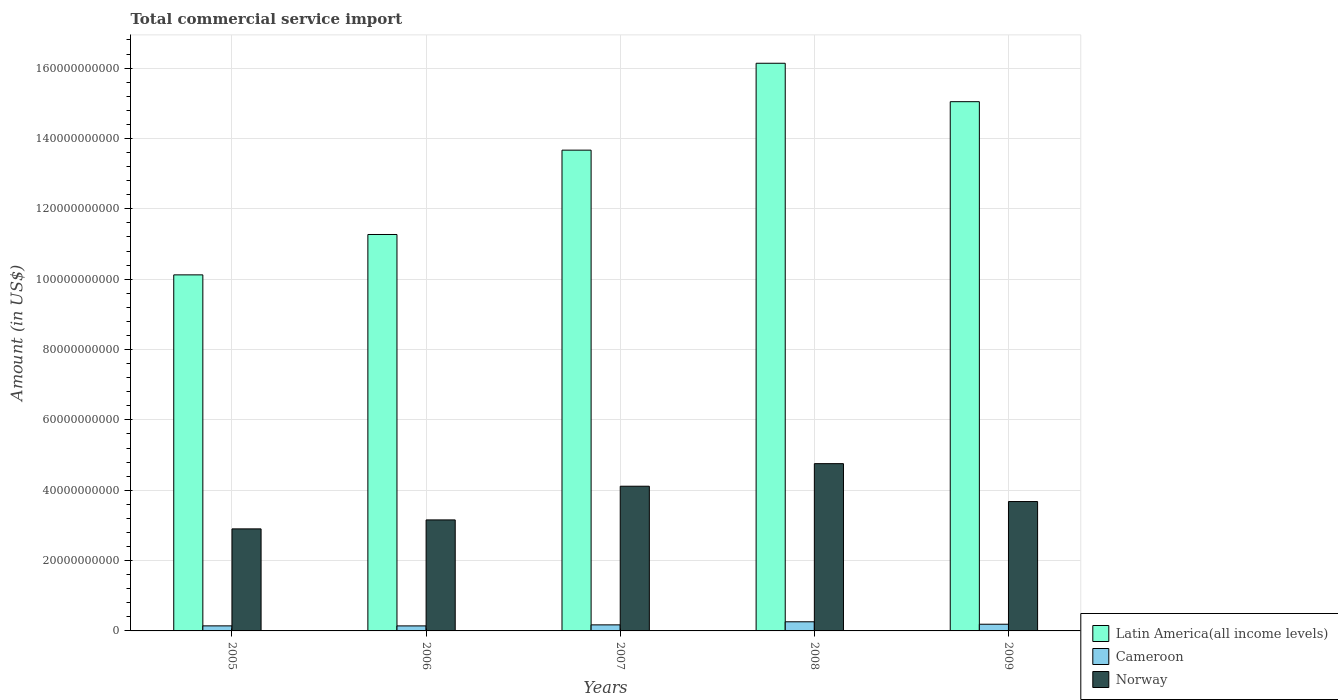How many groups of bars are there?
Your answer should be very brief. 5. Are the number of bars per tick equal to the number of legend labels?
Your answer should be compact. Yes. How many bars are there on the 5th tick from the left?
Make the answer very short. 3. What is the label of the 4th group of bars from the left?
Your answer should be compact. 2008. In how many cases, is the number of bars for a given year not equal to the number of legend labels?
Provide a short and direct response. 0. What is the total commercial service import in Norway in 2008?
Your answer should be very brief. 4.76e+1. Across all years, what is the maximum total commercial service import in Norway?
Provide a short and direct response. 4.76e+1. Across all years, what is the minimum total commercial service import in Cameroon?
Provide a succinct answer. 1.43e+09. In which year was the total commercial service import in Cameroon maximum?
Offer a very short reply. 2008. In which year was the total commercial service import in Norway minimum?
Your response must be concise. 2005. What is the total total commercial service import in Cameroon in the graph?
Your answer should be compact. 9.08e+09. What is the difference between the total commercial service import in Latin America(all income levels) in 2006 and that in 2009?
Your response must be concise. -3.78e+1. What is the difference between the total commercial service import in Latin America(all income levels) in 2007 and the total commercial service import in Norway in 2005?
Give a very brief answer. 1.08e+11. What is the average total commercial service import in Cameroon per year?
Offer a very short reply. 1.82e+09. In the year 2008, what is the difference between the total commercial service import in Norway and total commercial service import in Cameroon?
Give a very brief answer. 4.50e+1. In how many years, is the total commercial service import in Latin America(all income levels) greater than 128000000000 US$?
Keep it short and to the point. 3. What is the ratio of the total commercial service import in Cameroon in 2006 to that in 2007?
Offer a terse response. 0.83. Is the total commercial service import in Cameroon in 2008 less than that in 2009?
Offer a very short reply. No. Is the difference between the total commercial service import in Norway in 2006 and 2008 greater than the difference between the total commercial service import in Cameroon in 2006 and 2008?
Provide a short and direct response. No. What is the difference between the highest and the second highest total commercial service import in Norway?
Your answer should be compact. 6.42e+09. What is the difference between the highest and the lowest total commercial service import in Cameroon?
Your response must be concise. 1.17e+09. Is the sum of the total commercial service import in Norway in 2005 and 2007 greater than the maximum total commercial service import in Latin America(all income levels) across all years?
Give a very brief answer. No. What does the 3rd bar from the left in 2006 represents?
Offer a very short reply. Norway. How many bars are there?
Provide a succinct answer. 15. How many years are there in the graph?
Ensure brevity in your answer.  5. What is the difference between two consecutive major ticks on the Y-axis?
Make the answer very short. 2.00e+1. Does the graph contain grids?
Your response must be concise. Yes. How are the legend labels stacked?
Your answer should be compact. Vertical. What is the title of the graph?
Your answer should be compact. Total commercial service import. What is the label or title of the X-axis?
Offer a very short reply. Years. What is the label or title of the Y-axis?
Offer a terse response. Amount (in US$). What is the Amount (in US$) in Latin America(all income levels) in 2005?
Your answer should be compact. 1.01e+11. What is the Amount (in US$) of Cameroon in 2005?
Ensure brevity in your answer.  1.44e+09. What is the Amount (in US$) of Norway in 2005?
Your answer should be very brief. 2.90e+1. What is the Amount (in US$) of Latin America(all income levels) in 2006?
Ensure brevity in your answer.  1.13e+11. What is the Amount (in US$) in Cameroon in 2006?
Make the answer very short. 1.43e+09. What is the Amount (in US$) of Norway in 2006?
Your answer should be compact. 3.16e+1. What is the Amount (in US$) in Latin America(all income levels) in 2007?
Provide a succinct answer. 1.37e+11. What is the Amount (in US$) in Cameroon in 2007?
Give a very brief answer. 1.72e+09. What is the Amount (in US$) of Norway in 2007?
Ensure brevity in your answer.  4.11e+1. What is the Amount (in US$) in Latin America(all income levels) in 2008?
Offer a terse response. 1.61e+11. What is the Amount (in US$) in Cameroon in 2008?
Your answer should be very brief. 2.60e+09. What is the Amount (in US$) of Norway in 2008?
Offer a very short reply. 4.76e+1. What is the Amount (in US$) of Latin America(all income levels) in 2009?
Give a very brief answer. 1.50e+11. What is the Amount (in US$) in Cameroon in 2009?
Keep it short and to the point. 1.90e+09. What is the Amount (in US$) of Norway in 2009?
Offer a terse response. 3.68e+1. Across all years, what is the maximum Amount (in US$) of Latin America(all income levels)?
Give a very brief answer. 1.61e+11. Across all years, what is the maximum Amount (in US$) in Cameroon?
Give a very brief answer. 2.60e+09. Across all years, what is the maximum Amount (in US$) in Norway?
Your answer should be compact. 4.76e+1. Across all years, what is the minimum Amount (in US$) of Latin America(all income levels)?
Your answer should be compact. 1.01e+11. Across all years, what is the minimum Amount (in US$) in Cameroon?
Keep it short and to the point. 1.43e+09. Across all years, what is the minimum Amount (in US$) of Norway?
Make the answer very short. 2.90e+1. What is the total Amount (in US$) in Latin America(all income levels) in the graph?
Make the answer very short. 6.62e+11. What is the total Amount (in US$) in Cameroon in the graph?
Your answer should be compact. 9.08e+09. What is the total Amount (in US$) in Norway in the graph?
Provide a succinct answer. 1.86e+11. What is the difference between the Amount (in US$) in Latin America(all income levels) in 2005 and that in 2006?
Provide a short and direct response. -1.15e+1. What is the difference between the Amount (in US$) of Cameroon in 2005 and that in 2006?
Offer a terse response. 9.96e+06. What is the difference between the Amount (in US$) of Norway in 2005 and that in 2006?
Offer a terse response. -2.55e+09. What is the difference between the Amount (in US$) of Latin America(all income levels) in 2005 and that in 2007?
Ensure brevity in your answer.  -3.55e+1. What is the difference between the Amount (in US$) in Cameroon in 2005 and that in 2007?
Ensure brevity in your answer.  -2.83e+08. What is the difference between the Amount (in US$) in Norway in 2005 and that in 2007?
Make the answer very short. -1.21e+1. What is the difference between the Amount (in US$) of Latin America(all income levels) in 2005 and that in 2008?
Provide a succinct answer. -6.02e+1. What is the difference between the Amount (in US$) of Cameroon in 2005 and that in 2008?
Keep it short and to the point. -1.16e+09. What is the difference between the Amount (in US$) in Norway in 2005 and that in 2008?
Keep it short and to the point. -1.85e+1. What is the difference between the Amount (in US$) in Latin America(all income levels) in 2005 and that in 2009?
Give a very brief answer. -4.92e+1. What is the difference between the Amount (in US$) of Cameroon in 2005 and that in 2009?
Offer a terse response. -4.66e+08. What is the difference between the Amount (in US$) of Norway in 2005 and that in 2009?
Make the answer very short. -7.77e+09. What is the difference between the Amount (in US$) in Latin America(all income levels) in 2006 and that in 2007?
Provide a short and direct response. -2.40e+1. What is the difference between the Amount (in US$) in Cameroon in 2006 and that in 2007?
Offer a very short reply. -2.93e+08. What is the difference between the Amount (in US$) in Norway in 2006 and that in 2007?
Keep it short and to the point. -9.58e+09. What is the difference between the Amount (in US$) of Latin America(all income levels) in 2006 and that in 2008?
Your response must be concise. -4.87e+1. What is the difference between the Amount (in US$) of Cameroon in 2006 and that in 2008?
Keep it short and to the point. -1.17e+09. What is the difference between the Amount (in US$) of Norway in 2006 and that in 2008?
Make the answer very short. -1.60e+1. What is the difference between the Amount (in US$) in Latin America(all income levels) in 2006 and that in 2009?
Offer a very short reply. -3.78e+1. What is the difference between the Amount (in US$) of Cameroon in 2006 and that in 2009?
Keep it short and to the point. -4.75e+08. What is the difference between the Amount (in US$) in Norway in 2006 and that in 2009?
Give a very brief answer. -5.22e+09. What is the difference between the Amount (in US$) of Latin America(all income levels) in 2007 and that in 2008?
Give a very brief answer. -2.47e+1. What is the difference between the Amount (in US$) of Cameroon in 2007 and that in 2008?
Offer a very short reply. -8.77e+08. What is the difference between the Amount (in US$) in Norway in 2007 and that in 2008?
Provide a short and direct response. -6.42e+09. What is the difference between the Amount (in US$) in Latin America(all income levels) in 2007 and that in 2009?
Your answer should be compact. -1.38e+1. What is the difference between the Amount (in US$) of Cameroon in 2007 and that in 2009?
Your answer should be very brief. -1.83e+08. What is the difference between the Amount (in US$) of Norway in 2007 and that in 2009?
Offer a very short reply. 4.35e+09. What is the difference between the Amount (in US$) in Latin America(all income levels) in 2008 and that in 2009?
Offer a very short reply. 1.09e+1. What is the difference between the Amount (in US$) of Cameroon in 2008 and that in 2009?
Ensure brevity in your answer.  6.94e+08. What is the difference between the Amount (in US$) in Norway in 2008 and that in 2009?
Provide a short and direct response. 1.08e+1. What is the difference between the Amount (in US$) in Latin America(all income levels) in 2005 and the Amount (in US$) in Cameroon in 2006?
Your answer should be very brief. 9.98e+1. What is the difference between the Amount (in US$) of Latin America(all income levels) in 2005 and the Amount (in US$) of Norway in 2006?
Keep it short and to the point. 6.97e+1. What is the difference between the Amount (in US$) in Cameroon in 2005 and the Amount (in US$) in Norway in 2006?
Provide a succinct answer. -3.01e+1. What is the difference between the Amount (in US$) of Latin America(all income levels) in 2005 and the Amount (in US$) of Cameroon in 2007?
Keep it short and to the point. 9.95e+1. What is the difference between the Amount (in US$) of Latin America(all income levels) in 2005 and the Amount (in US$) of Norway in 2007?
Provide a succinct answer. 6.01e+1. What is the difference between the Amount (in US$) in Cameroon in 2005 and the Amount (in US$) in Norway in 2007?
Give a very brief answer. -3.97e+1. What is the difference between the Amount (in US$) of Latin America(all income levels) in 2005 and the Amount (in US$) of Cameroon in 2008?
Ensure brevity in your answer.  9.86e+1. What is the difference between the Amount (in US$) in Latin America(all income levels) in 2005 and the Amount (in US$) in Norway in 2008?
Offer a terse response. 5.37e+1. What is the difference between the Amount (in US$) in Cameroon in 2005 and the Amount (in US$) in Norway in 2008?
Your answer should be compact. -4.61e+1. What is the difference between the Amount (in US$) of Latin America(all income levels) in 2005 and the Amount (in US$) of Cameroon in 2009?
Offer a very short reply. 9.93e+1. What is the difference between the Amount (in US$) in Latin America(all income levels) in 2005 and the Amount (in US$) in Norway in 2009?
Offer a terse response. 6.44e+1. What is the difference between the Amount (in US$) of Cameroon in 2005 and the Amount (in US$) of Norway in 2009?
Ensure brevity in your answer.  -3.53e+1. What is the difference between the Amount (in US$) in Latin America(all income levels) in 2006 and the Amount (in US$) in Cameroon in 2007?
Make the answer very short. 1.11e+11. What is the difference between the Amount (in US$) of Latin America(all income levels) in 2006 and the Amount (in US$) of Norway in 2007?
Ensure brevity in your answer.  7.16e+1. What is the difference between the Amount (in US$) of Cameroon in 2006 and the Amount (in US$) of Norway in 2007?
Provide a succinct answer. -3.97e+1. What is the difference between the Amount (in US$) of Latin America(all income levels) in 2006 and the Amount (in US$) of Cameroon in 2008?
Provide a short and direct response. 1.10e+11. What is the difference between the Amount (in US$) in Latin America(all income levels) in 2006 and the Amount (in US$) in Norway in 2008?
Offer a terse response. 6.51e+1. What is the difference between the Amount (in US$) of Cameroon in 2006 and the Amount (in US$) of Norway in 2008?
Offer a very short reply. -4.61e+1. What is the difference between the Amount (in US$) in Latin America(all income levels) in 2006 and the Amount (in US$) in Cameroon in 2009?
Your response must be concise. 1.11e+11. What is the difference between the Amount (in US$) in Latin America(all income levels) in 2006 and the Amount (in US$) in Norway in 2009?
Your answer should be very brief. 7.59e+1. What is the difference between the Amount (in US$) in Cameroon in 2006 and the Amount (in US$) in Norway in 2009?
Provide a short and direct response. -3.54e+1. What is the difference between the Amount (in US$) in Latin America(all income levels) in 2007 and the Amount (in US$) in Cameroon in 2008?
Provide a succinct answer. 1.34e+11. What is the difference between the Amount (in US$) in Latin America(all income levels) in 2007 and the Amount (in US$) in Norway in 2008?
Your answer should be very brief. 8.91e+1. What is the difference between the Amount (in US$) in Cameroon in 2007 and the Amount (in US$) in Norway in 2008?
Your answer should be compact. -4.58e+1. What is the difference between the Amount (in US$) of Latin America(all income levels) in 2007 and the Amount (in US$) of Cameroon in 2009?
Give a very brief answer. 1.35e+11. What is the difference between the Amount (in US$) in Latin America(all income levels) in 2007 and the Amount (in US$) in Norway in 2009?
Give a very brief answer. 9.99e+1. What is the difference between the Amount (in US$) in Cameroon in 2007 and the Amount (in US$) in Norway in 2009?
Offer a very short reply. -3.51e+1. What is the difference between the Amount (in US$) in Latin America(all income levels) in 2008 and the Amount (in US$) in Cameroon in 2009?
Make the answer very short. 1.59e+11. What is the difference between the Amount (in US$) of Latin America(all income levels) in 2008 and the Amount (in US$) of Norway in 2009?
Your answer should be very brief. 1.25e+11. What is the difference between the Amount (in US$) in Cameroon in 2008 and the Amount (in US$) in Norway in 2009?
Your response must be concise. -3.42e+1. What is the average Amount (in US$) in Latin America(all income levels) per year?
Provide a succinct answer. 1.32e+11. What is the average Amount (in US$) of Cameroon per year?
Provide a short and direct response. 1.82e+09. What is the average Amount (in US$) of Norway per year?
Make the answer very short. 3.72e+1. In the year 2005, what is the difference between the Amount (in US$) in Latin America(all income levels) and Amount (in US$) in Cameroon?
Your answer should be compact. 9.98e+1. In the year 2005, what is the difference between the Amount (in US$) of Latin America(all income levels) and Amount (in US$) of Norway?
Your response must be concise. 7.22e+1. In the year 2005, what is the difference between the Amount (in US$) of Cameroon and Amount (in US$) of Norway?
Give a very brief answer. -2.76e+1. In the year 2006, what is the difference between the Amount (in US$) in Latin America(all income levels) and Amount (in US$) in Cameroon?
Keep it short and to the point. 1.11e+11. In the year 2006, what is the difference between the Amount (in US$) in Latin America(all income levels) and Amount (in US$) in Norway?
Provide a succinct answer. 8.11e+1. In the year 2006, what is the difference between the Amount (in US$) of Cameroon and Amount (in US$) of Norway?
Make the answer very short. -3.01e+1. In the year 2007, what is the difference between the Amount (in US$) in Latin America(all income levels) and Amount (in US$) in Cameroon?
Provide a succinct answer. 1.35e+11. In the year 2007, what is the difference between the Amount (in US$) in Latin America(all income levels) and Amount (in US$) in Norway?
Provide a short and direct response. 9.55e+1. In the year 2007, what is the difference between the Amount (in US$) of Cameroon and Amount (in US$) of Norway?
Ensure brevity in your answer.  -3.94e+1. In the year 2008, what is the difference between the Amount (in US$) in Latin America(all income levels) and Amount (in US$) in Cameroon?
Provide a short and direct response. 1.59e+11. In the year 2008, what is the difference between the Amount (in US$) of Latin America(all income levels) and Amount (in US$) of Norway?
Provide a short and direct response. 1.14e+11. In the year 2008, what is the difference between the Amount (in US$) in Cameroon and Amount (in US$) in Norway?
Your answer should be compact. -4.50e+1. In the year 2009, what is the difference between the Amount (in US$) of Latin America(all income levels) and Amount (in US$) of Cameroon?
Make the answer very short. 1.49e+11. In the year 2009, what is the difference between the Amount (in US$) of Latin America(all income levels) and Amount (in US$) of Norway?
Your response must be concise. 1.14e+11. In the year 2009, what is the difference between the Amount (in US$) in Cameroon and Amount (in US$) in Norway?
Keep it short and to the point. -3.49e+1. What is the ratio of the Amount (in US$) of Latin America(all income levels) in 2005 to that in 2006?
Make the answer very short. 0.9. What is the ratio of the Amount (in US$) of Norway in 2005 to that in 2006?
Ensure brevity in your answer.  0.92. What is the ratio of the Amount (in US$) in Latin America(all income levels) in 2005 to that in 2007?
Ensure brevity in your answer.  0.74. What is the ratio of the Amount (in US$) in Cameroon in 2005 to that in 2007?
Give a very brief answer. 0.84. What is the ratio of the Amount (in US$) of Norway in 2005 to that in 2007?
Make the answer very short. 0.71. What is the ratio of the Amount (in US$) of Latin America(all income levels) in 2005 to that in 2008?
Offer a terse response. 0.63. What is the ratio of the Amount (in US$) of Cameroon in 2005 to that in 2008?
Make the answer very short. 0.55. What is the ratio of the Amount (in US$) in Norway in 2005 to that in 2008?
Give a very brief answer. 0.61. What is the ratio of the Amount (in US$) of Latin America(all income levels) in 2005 to that in 2009?
Your response must be concise. 0.67. What is the ratio of the Amount (in US$) in Cameroon in 2005 to that in 2009?
Ensure brevity in your answer.  0.76. What is the ratio of the Amount (in US$) in Norway in 2005 to that in 2009?
Make the answer very short. 0.79. What is the ratio of the Amount (in US$) in Latin America(all income levels) in 2006 to that in 2007?
Keep it short and to the point. 0.82. What is the ratio of the Amount (in US$) of Cameroon in 2006 to that in 2007?
Provide a short and direct response. 0.83. What is the ratio of the Amount (in US$) of Norway in 2006 to that in 2007?
Give a very brief answer. 0.77. What is the ratio of the Amount (in US$) in Latin America(all income levels) in 2006 to that in 2008?
Keep it short and to the point. 0.7. What is the ratio of the Amount (in US$) of Cameroon in 2006 to that in 2008?
Provide a succinct answer. 0.55. What is the ratio of the Amount (in US$) in Norway in 2006 to that in 2008?
Keep it short and to the point. 0.66. What is the ratio of the Amount (in US$) in Latin America(all income levels) in 2006 to that in 2009?
Provide a succinct answer. 0.75. What is the ratio of the Amount (in US$) of Cameroon in 2006 to that in 2009?
Ensure brevity in your answer.  0.75. What is the ratio of the Amount (in US$) in Norway in 2006 to that in 2009?
Your answer should be very brief. 0.86. What is the ratio of the Amount (in US$) in Latin America(all income levels) in 2007 to that in 2008?
Offer a terse response. 0.85. What is the ratio of the Amount (in US$) in Cameroon in 2007 to that in 2008?
Make the answer very short. 0.66. What is the ratio of the Amount (in US$) of Norway in 2007 to that in 2008?
Make the answer very short. 0.86. What is the ratio of the Amount (in US$) in Latin America(all income levels) in 2007 to that in 2009?
Offer a terse response. 0.91. What is the ratio of the Amount (in US$) of Cameroon in 2007 to that in 2009?
Offer a terse response. 0.9. What is the ratio of the Amount (in US$) of Norway in 2007 to that in 2009?
Give a very brief answer. 1.12. What is the ratio of the Amount (in US$) of Latin America(all income levels) in 2008 to that in 2009?
Offer a very short reply. 1.07. What is the ratio of the Amount (in US$) in Cameroon in 2008 to that in 2009?
Your answer should be compact. 1.36. What is the ratio of the Amount (in US$) of Norway in 2008 to that in 2009?
Offer a terse response. 1.29. What is the difference between the highest and the second highest Amount (in US$) in Latin America(all income levels)?
Your answer should be very brief. 1.09e+1. What is the difference between the highest and the second highest Amount (in US$) of Cameroon?
Give a very brief answer. 6.94e+08. What is the difference between the highest and the second highest Amount (in US$) of Norway?
Offer a terse response. 6.42e+09. What is the difference between the highest and the lowest Amount (in US$) of Latin America(all income levels)?
Keep it short and to the point. 6.02e+1. What is the difference between the highest and the lowest Amount (in US$) in Cameroon?
Offer a terse response. 1.17e+09. What is the difference between the highest and the lowest Amount (in US$) of Norway?
Provide a short and direct response. 1.85e+1. 